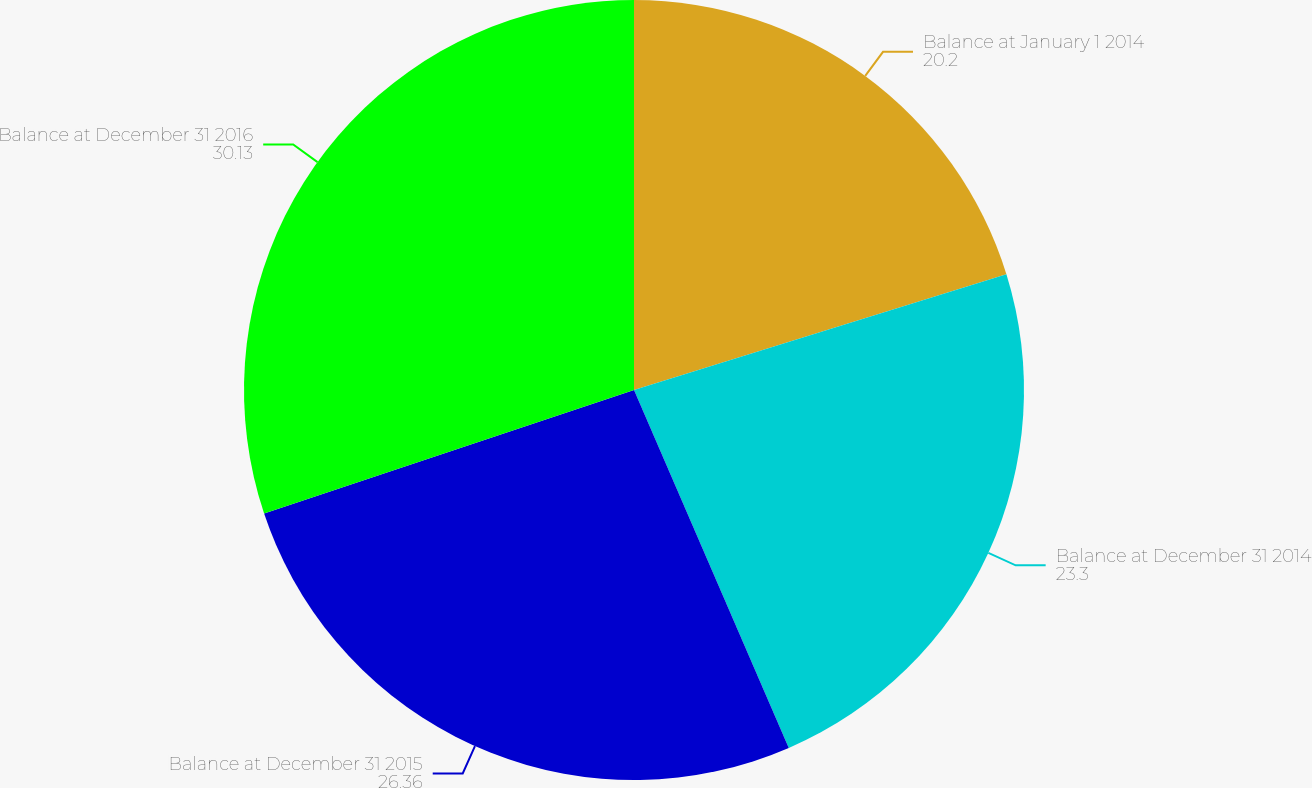<chart> <loc_0><loc_0><loc_500><loc_500><pie_chart><fcel>Balance at January 1 2014<fcel>Balance at December 31 2014<fcel>Balance at December 31 2015<fcel>Balance at December 31 2016<nl><fcel>20.2%<fcel>23.3%<fcel>26.36%<fcel>30.13%<nl></chart> 